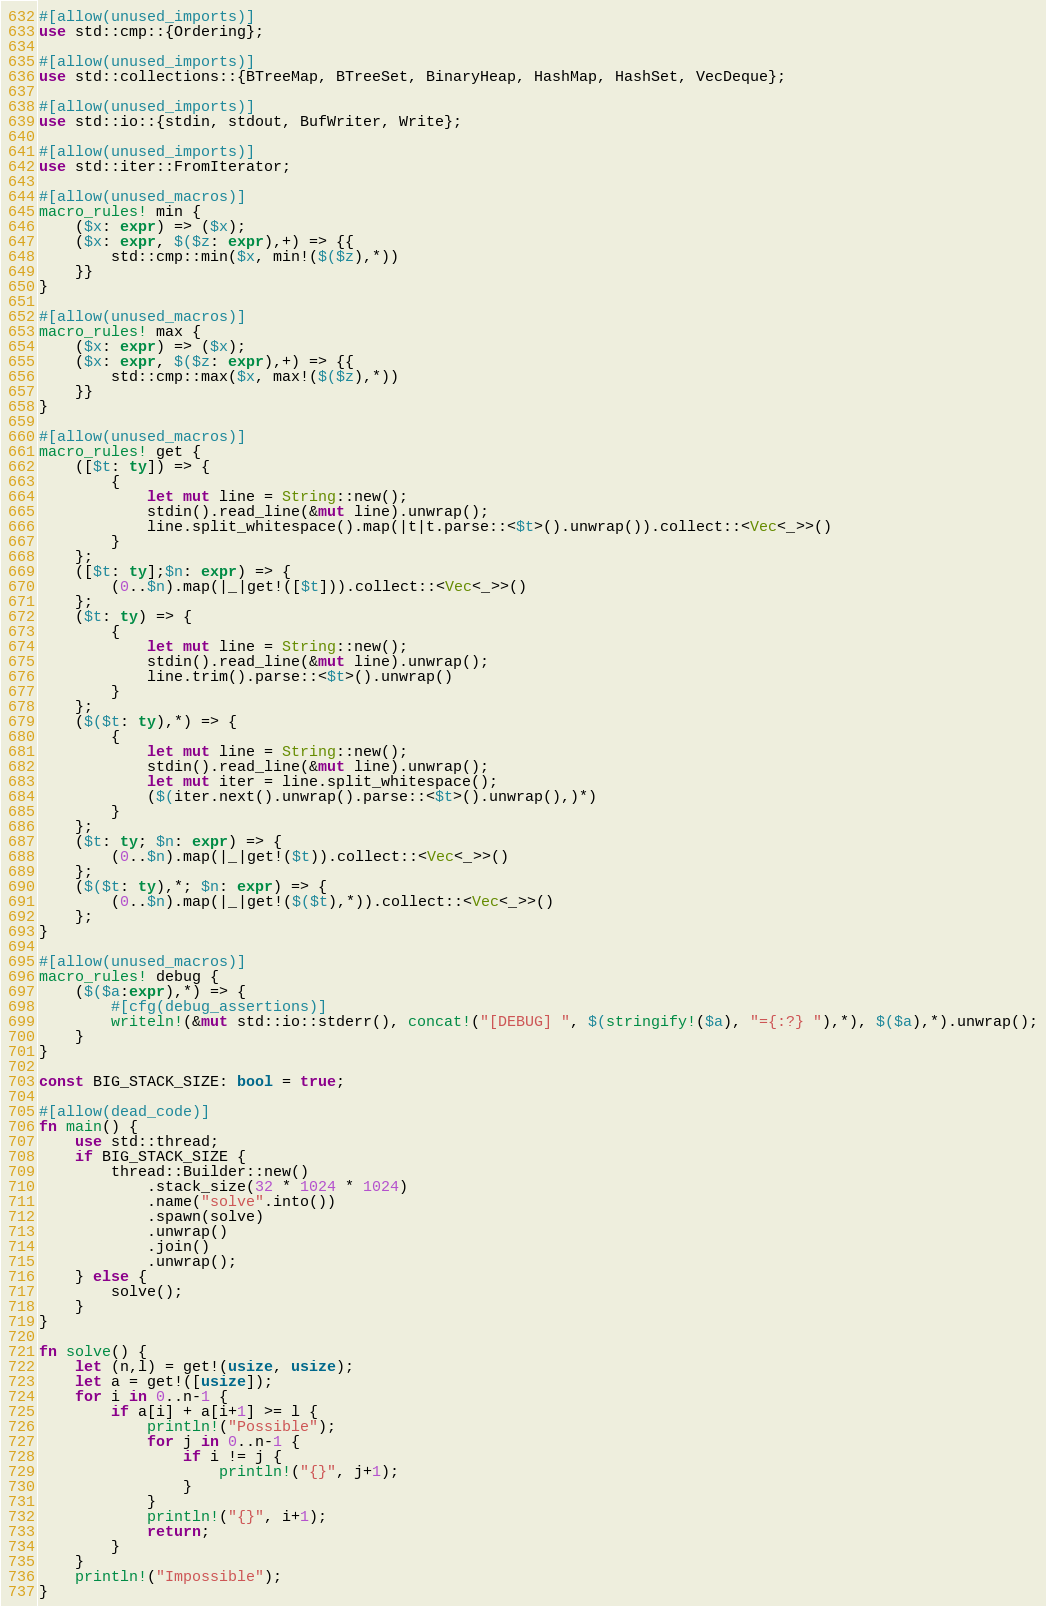<code> <loc_0><loc_0><loc_500><loc_500><_Rust_>#[allow(unused_imports)]
use std::cmp::{Ordering};

#[allow(unused_imports)]
use std::collections::{BTreeMap, BTreeSet, BinaryHeap, HashMap, HashSet, VecDeque};

#[allow(unused_imports)]
use std::io::{stdin, stdout, BufWriter, Write};

#[allow(unused_imports)]
use std::iter::FromIterator;

#[allow(unused_macros)]
macro_rules! min {
    ($x: expr) => ($x);
    ($x: expr, $($z: expr),+) => {{
        std::cmp::min($x, min!($($z),*))
    }}
}

#[allow(unused_macros)]
macro_rules! max {
    ($x: expr) => ($x);
    ($x: expr, $($z: expr),+) => {{
        std::cmp::max($x, max!($($z),*))
    }}
}

#[allow(unused_macros)]
macro_rules! get { 
    ([$t: ty]) => { 
        { 
            let mut line = String::new(); 
            stdin().read_line(&mut line).unwrap(); 
            line.split_whitespace().map(|t|t.parse::<$t>().unwrap()).collect::<Vec<_>>()
        }
    };
    ([$t: ty];$n: expr) => {
        (0..$n).map(|_|get!([$t])).collect::<Vec<_>>()
    };
    ($t: ty) => {
        {
            let mut line = String::new();
            stdin().read_line(&mut line).unwrap();
            line.trim().parse::<$t>().unwrap()
        }
    };
    ($($t: ty),*) => {
        { 
            let mut line = String::new();
            stdin().read_line(&mut line).unwrap();
            let mut iter = line.split_whitespace();
            ($(iter.next().unwrap().parse::<$t>().unwrap(),)*)
        }
    };
    ($t: ty; $n: expr) => {
        (0..$n).map(|_|get!($t)).collect::<Vec<_>>()
    };
    ($($t: ty),*; $n: expr) => {
        (0..$n).map(|_|get!($($t),*)).collect::<Vec<_>>()
    };
}

#[allow(unused_macros)]
macro_rules! debug {
    ($($a:expr),*) => {
        #[cfg(debug_assertions)]
        writeln!(&mut std::io::stderr(), concat!("[DEBUG] ", $(stringify!($a), "={:?} "),*), $($a),*).unwrap();
    }
}

const BIG_STACK_SIZE: bool = true;

#[allow(dead_code)]
fn main() {
    use std::thread;
    if BIG_STACK_SIZE {
        thread::Builder::new()
            .stack_size(32 * 1024 * 1024)
            .name("solve".into())
            .spawn(solve)
            .unwrap()
            .join()
            .unwrap();
    } else {
        solve();
    }
}

fn solve() {
    let (n,l) = get!(usize, usize);
    let a = get!([usize]);
    for i in 0..n-1 {
        if a[i] + a[i+1] >= l {
            println!("Possible");
            for j in 0..n-1 {
                if i != j {
                    println!("{}", j+1);
                }
            }
            println!("{}", i+1);
            return;
        }
    }
    println!("Impossible");
}
</code> 